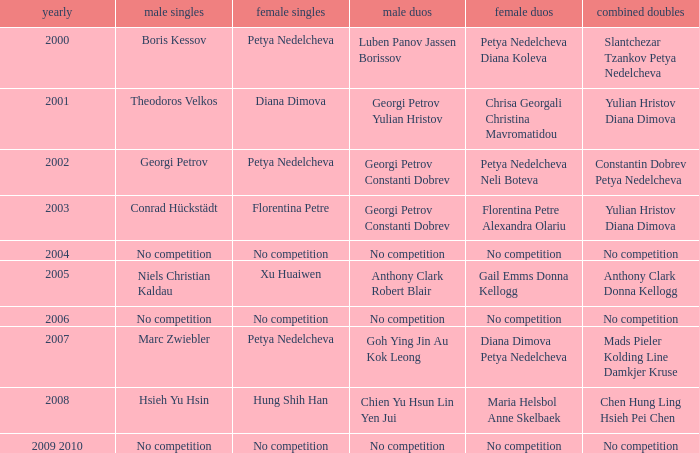Who won the Men's Double the same year as Florentina Petre winning the Women's Singles? Georgi Petrov Constanti Dobrev. 